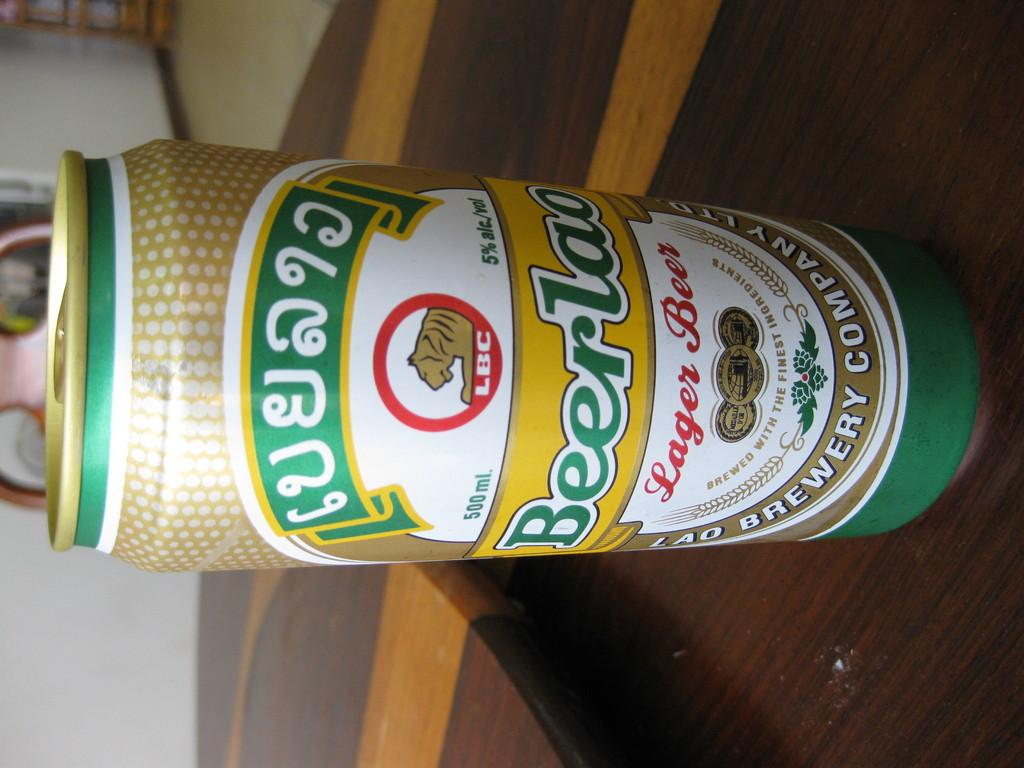<image>
Give a short and clear explanation of the subsequent image. a beer can that is green in color 